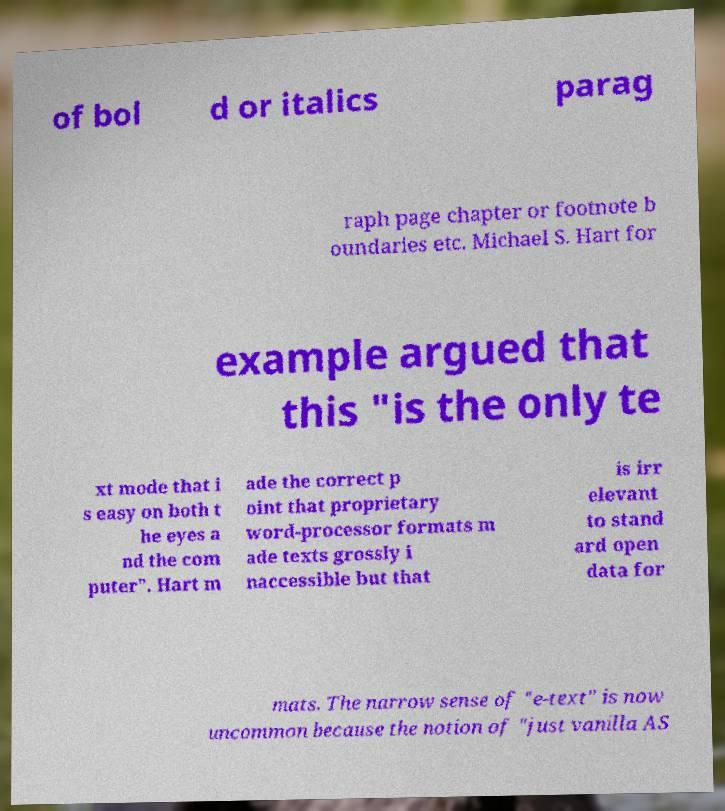Please read and relay the text visible in this image. What does it say? of bol d or italics parag raph page chapter or footnote b oundaries etc. Michael S. Hart for example argued that this "is the only te xt mode that i s easy on both t he eyes a nd the com puter". Hart m ade the correct p oint that proprietary word-processor formats m ade texts grossly i naccessible but that is irr elevant to stand ard open data for mats. The narrow sense of "e-text" is now uncommon because the notion of "just vanilla AS 